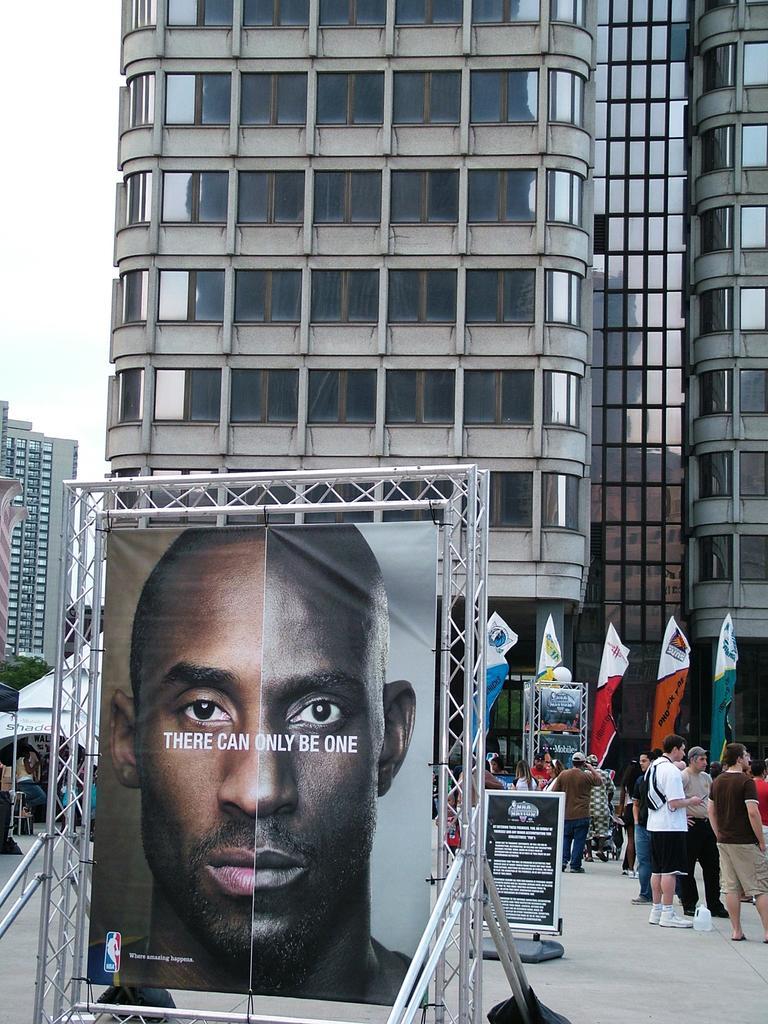Could you give a brief overview of what you see in this image? In this image we can see there are buildings and banners. In front of the building there are a few people standing and few people walking. And there are banners attached to the stands. There is the pole and the sky. 